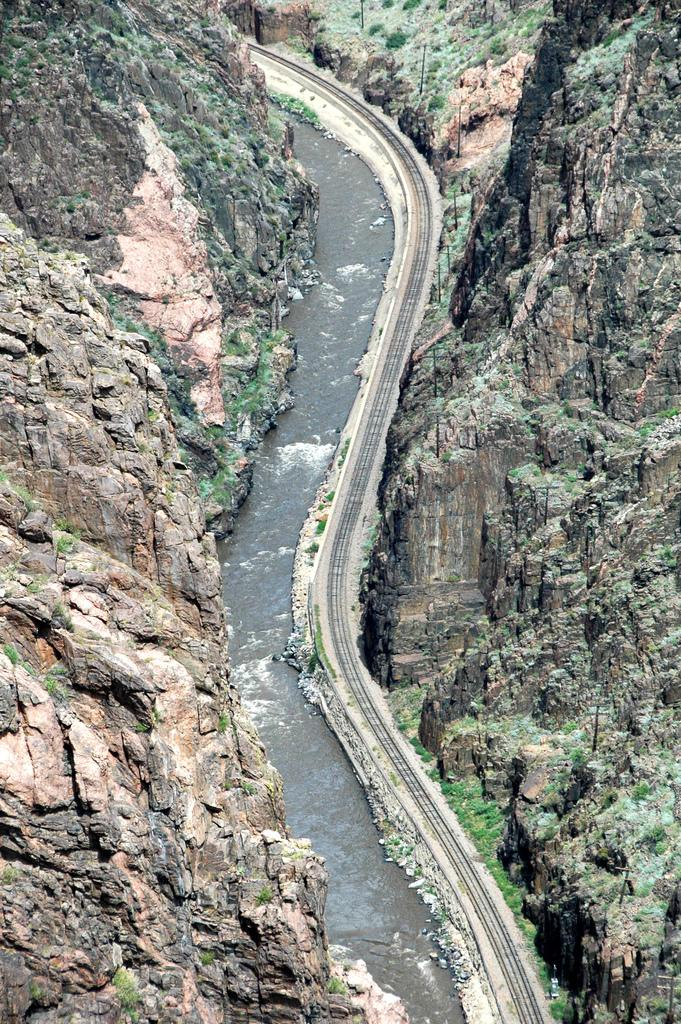What is the main feature of the image? There is a road in the image. What can be seen beside the road? There is water beside the road. What is located on the left side of the image? There is a mountain and grass on the left side of the image. What is located on the right side of the image? There is a mountain and grass on the right side of the image. What type of brush is the grandfather using in the image? There is no grandfather or brush present in the image. 